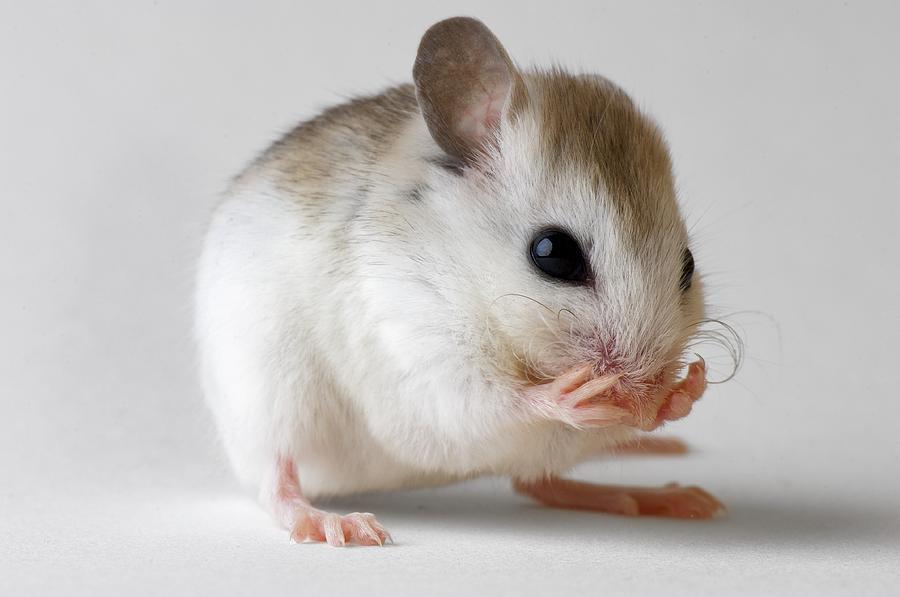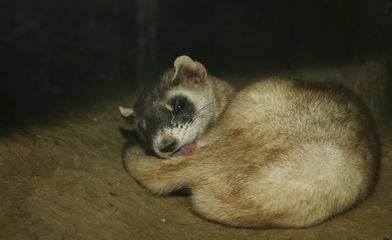The first image is the image on the left, the second image is the image on the right. Given the left and right images, does the statement "There is an animal that is not a ferret." hold true? Answer yes or no. Yes. 